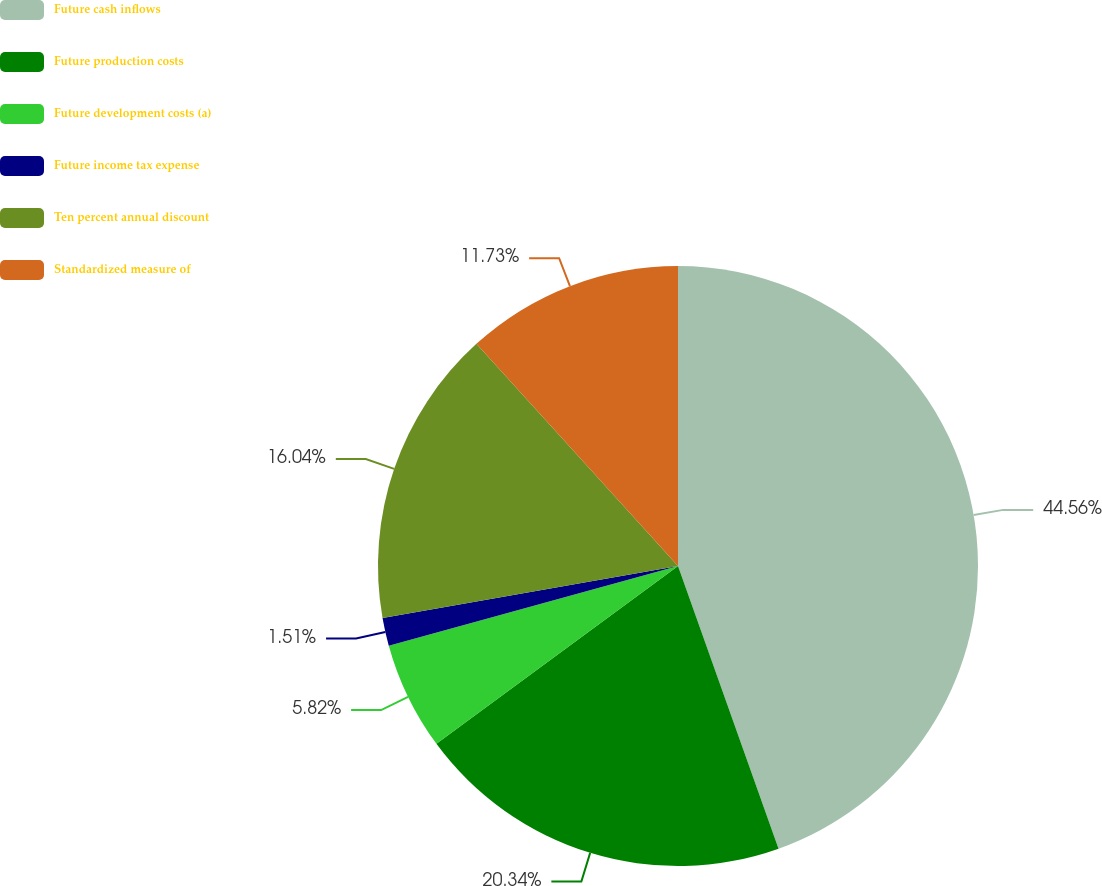Convert chart. <chart><loc_0><loc_0><loc_500><loc_500><pie_chart><fcel>Future cash inflows<fcel>Future production costs<fcel>Future development costs (a)<fcel>Future income tax expense<fcel>Ten percent annual discount<fcel>Standardized measure of<nl><fcel>44.56%<fcel>20.34%<fcel>5.82%<fcel>1.51%<fcel>16.04%<fcel>11.73%<nl></chart> 